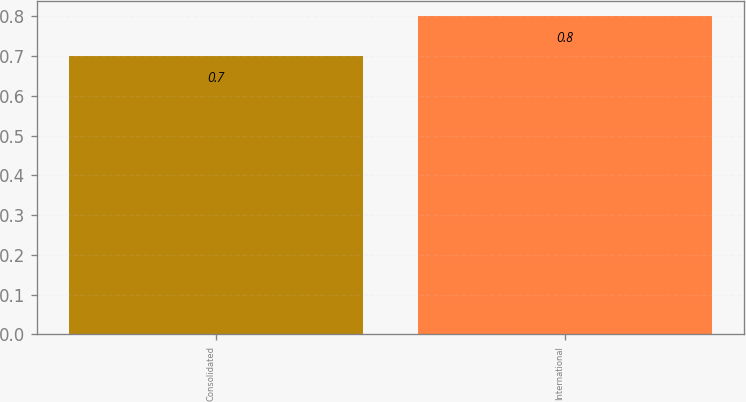Convert chart. <chart><loc_0><loc_0><loc_500><loc_500><bar_chart><fcel>Consolidated<fcel>International<nl><fcel>0.7<fcel>0.8<nl></chart> 